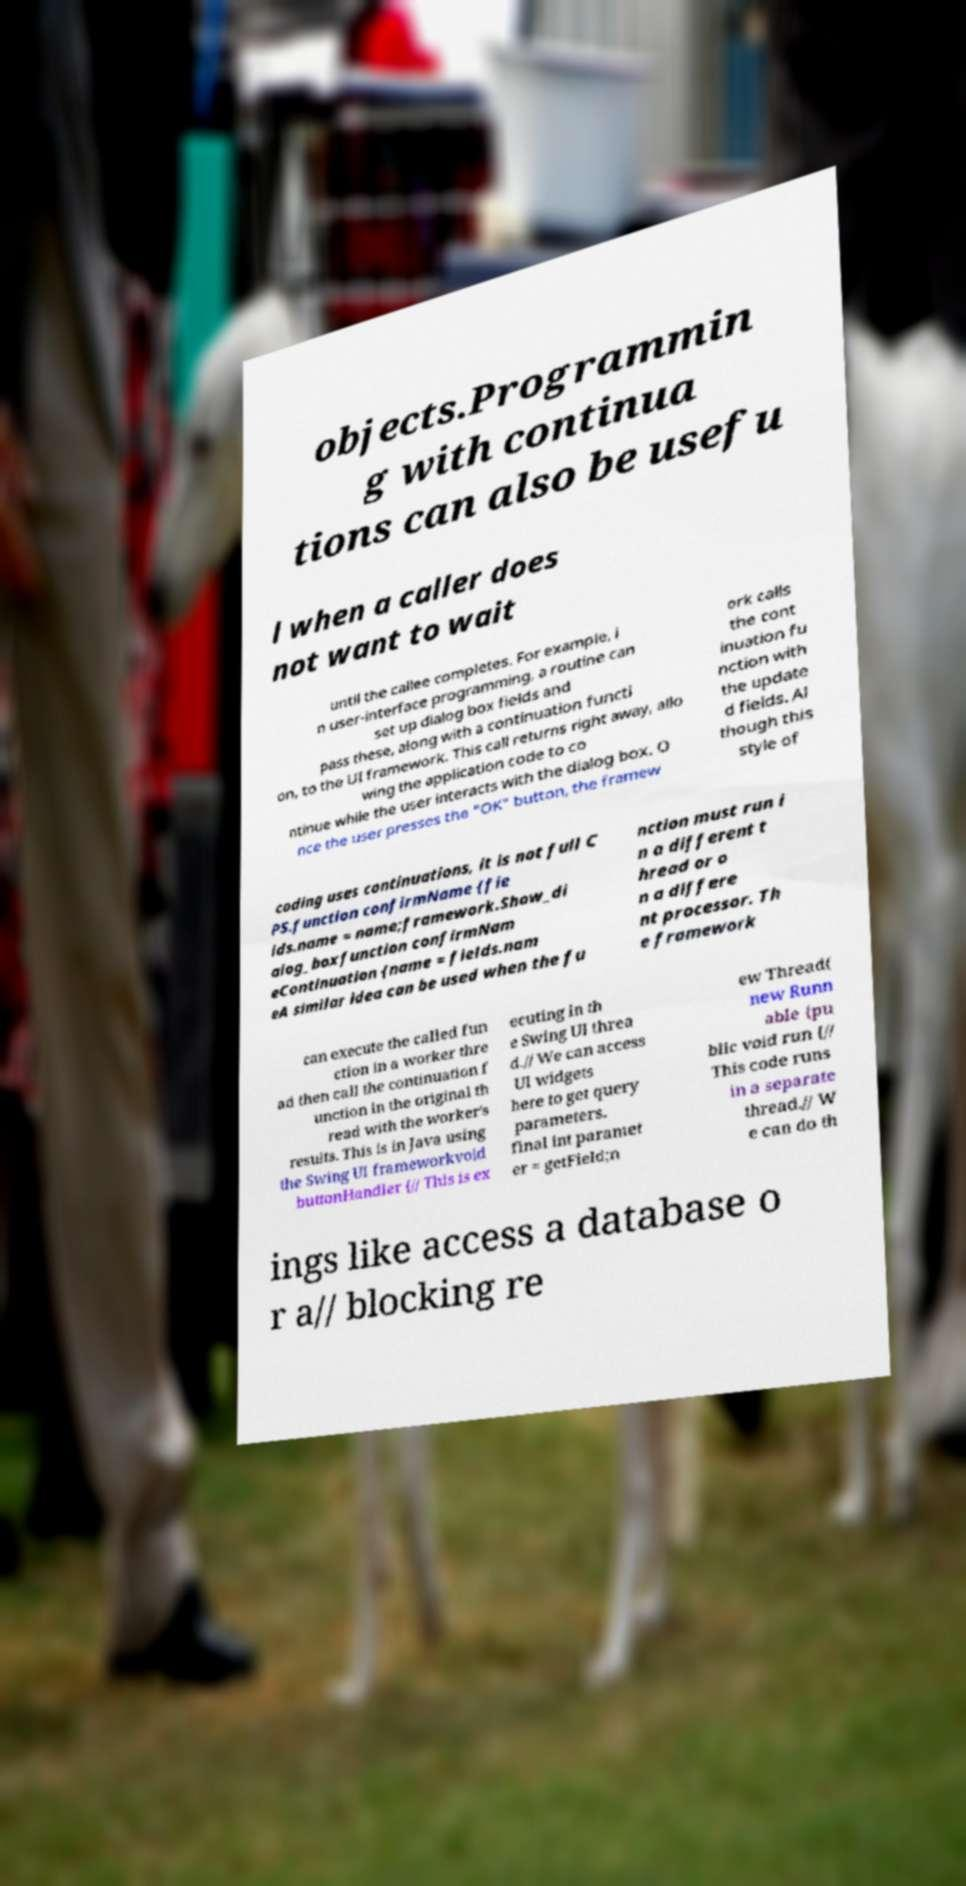Please read and relay the text visible in this image. What does it say? objects.Programmin g with continua tions can also be usefu l when a caller does not want to wait until the callee completes. For example, i n user-interface programming, a routine can set up dialog box fields and pass these, along with a continuation functi on, to the UI framework. This call returns right away, allo wing the application code to co ntinue while the user interacts with the dialog box. O nce the user presses the "OK" button, the framew ork calls the cont inuation fu nction with the update d fields. Al though this style of coding uses continuations, it is not full C PS.function confirmName {fie lds.name = name;framework.Show_di alog_boxfunction confirmNam eContinuation {name = fields.nam eA similar idea can be used when the fu nction must run i n a different t hread or o n a differe nt processor. Th e framework can execute the called fun ction in a worker thre ad then call the continuation f unction in the original th read with the worker's results. This is in Java using the Swing UI frameworkvoid buttonHandler {// This is ex ecuting in th e Swing UI threa d.// We can access UI widgets here to get query parameters. final int paramet er = getField;n ew Thread( new Runn able {pu blic void run {// This code runs in a separate thread.// W e can do th ings like access a database o r a// blocking re 